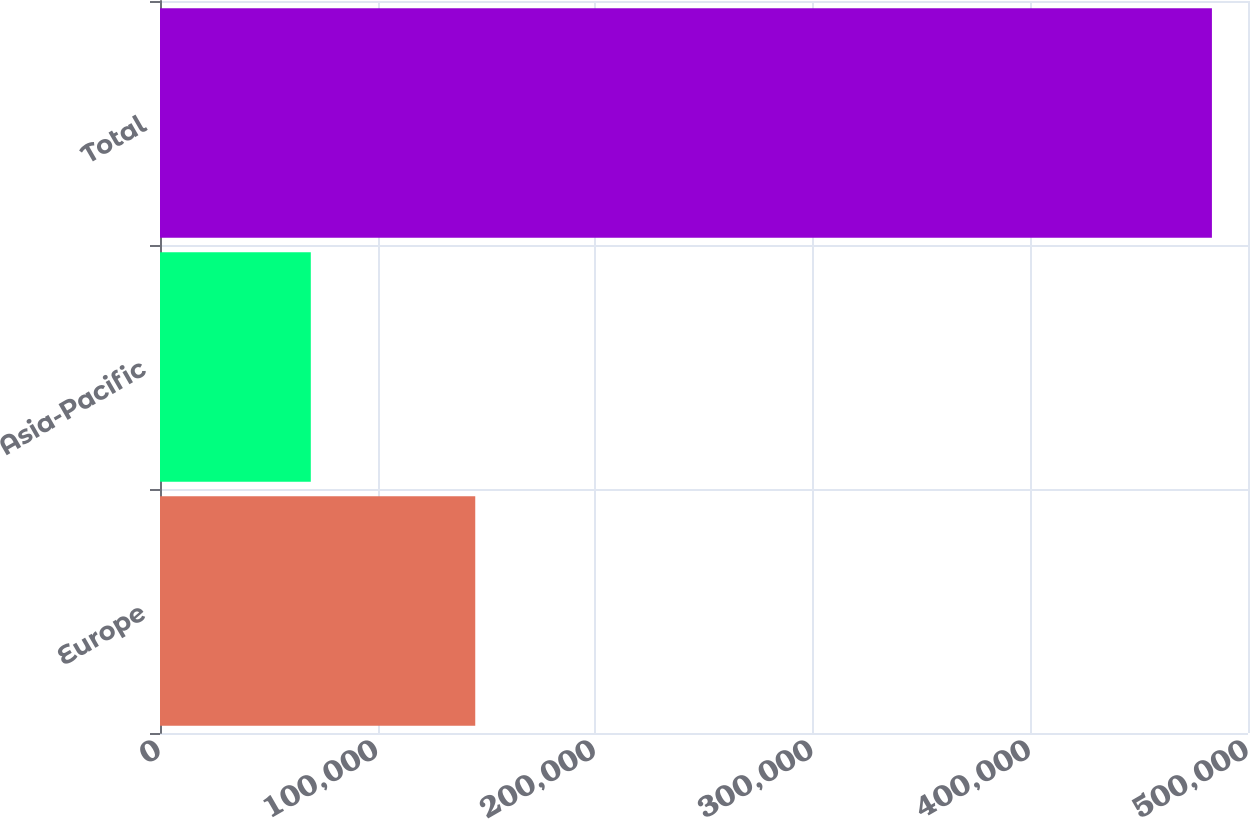<chart> <loc_0><loc_0><loc_500><loc_500><bar_chart><fcel>Europe<fcel>Asia-Pacific<fcel>Total<nl><fcel>144875<fcel>69303<fcel>483420<nl></chart> 